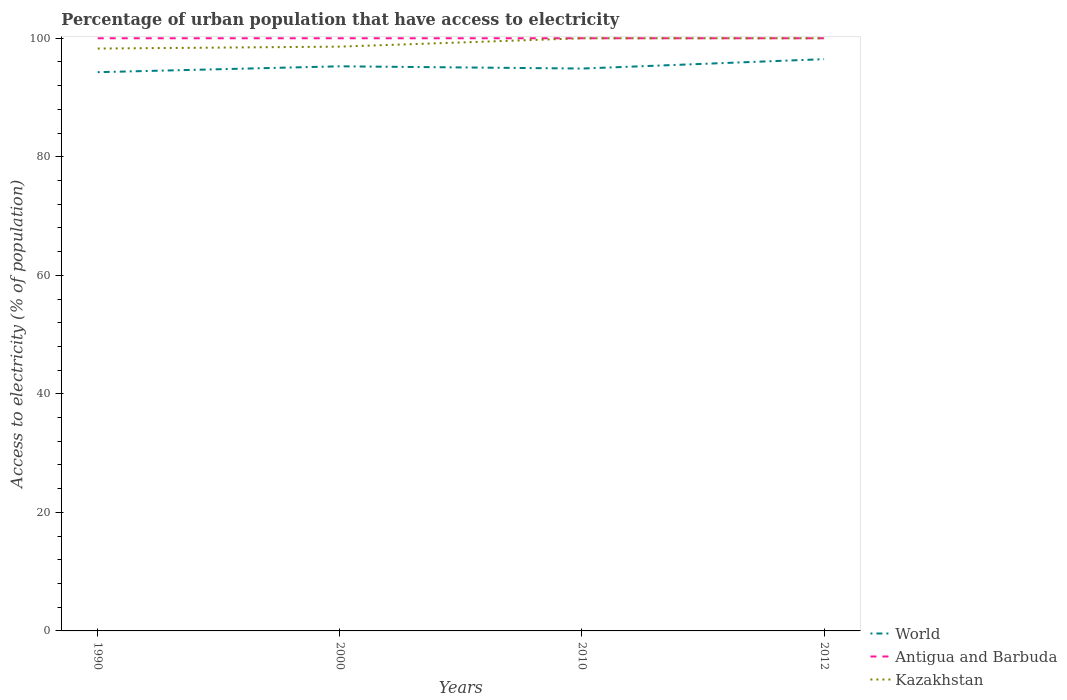Is the number of lines equal to the number of legend labels?
Your answer should be compact. Yes. Across all years, what is the maximum percentage of urban population that have access to electricity in Kazakhstan?
Ensure brevity in your answer.  98.26. What is the difference between two consecutive major ticks on the Y-axis?
Ensure brevity in your answer.  20. Are the values on the major ticks of Y-axis written in scientific E-notation?
Your answer should be very brief. No. Does the graph contain any zero values?
Keep it short and to the point. No. Does the graph contain grids?
Your answer should be very brief. No. How are the legend labels stacked?
Provide a short and direct response. Vertical. What is the title of the graph?
Provide a short and direct response. Percentage of urban population that have access to electricity. What is the label or title of the X-axis?
Provide a succinct answer. Years. What is the label or title of the Y-axis?
Provide a short and direct response. Access to electricity (% of population). What is the Access to electricity (% of population) of World in 1990?
Keep it short and to the point. 94.28. What is the Access to electricity (% of population) in Kazakhstan in 1990?
Ensure brevity in your answer.  98.26. What is the Access to electricity (% of population) in World in 2000?
Offer a terse response. 95.27. What is the Access to electricity (% of population) in Kazakhstan in 2000?
Your answer should be very brief. 98.59. What is the Access to electricity (% of population) in World in 2010?
Offer a very short reply. 94.89. What is the Access to electricity (% of population) in Antigua and Barbuda in 2010?
Provide a short and direct response. 100. What is the Access to electricity (% of population) of Kazakhstan in 2010?
Your response must be concise. 100. What is the Access to electricity (% of population) of World in 2012?
Provide a short and direct response. 96.48. What is the Access to electricity (% of population) of Antigua and Barbuda in 2012?
Your answer should be very brief. 100. Across all years, what is the maximum Access to electricity (% of population) in World?
Your answer should be very brief. 96.48. Across all years, what is the maximum Access to electricity (% of population) of Antigua and Barbuda?
Offer a very short reply. 100. Across all years, what is the minimum Access to electricity (% of population) in World?
Your answer should be compact. 94.28. Across all years, what is the minimum Access to electricity (% of population) in Antigua and Barbuda?
Give a very brief answer. 100. Across all years, what is the minimum Access to electricity (% of population) in Kazakhstan?
Offer a terse response. 98.26. What is the total Access to electricity (% of population) of World in the graph?
Keep it short and to the point. 380.92. What is the total Access to electricity (% of population) of Antigua and Barbuda in the graph?
Ensure brevity in your answer.  400. What is the total Access to electricity (% of population) in Kazakhstan in the graph?
Provide a short and direct response. 396.85. What is the difference between the Access to electricity (% of population) in World in 1990 and that in 2000?
Your answer should be compact. -0.99. What is the difference between the Access to electricity (% of population) of Antigua and Barbuda in 1990 and that in 2000?
Give a very brief answer. 0. What is the difference between the Access to electricity (% of population) in Kazakhstan in 1990 and that in 2000?
Give a very brief answer. -0.32. What is the difference between the Access to electricity (% of population) of World in 1990 and that in 2010?
Give a very brief answer. -0.61. What is the difference between the Access to electricity (% of population) of Antigua and Barbuda in 1990 and that in 2010?
Your response must be concise. 0. What is the difference between the Access to electricity (% of population) in Kazakhstan in 1990 and that in 2010?
Give a very brief answer. -1.74. What is the difference between the Access to electricity (% of population) in World in 1990 and that in 2012?
Your answer should be very brief. -2.2. What is the difference between the Access to electricity (% of population) in Kazakhstan in 1990 and that in 2012?
Provide a succinct answer. -1.74. What is the difference between the Access to electricity (% of population) of World in 2000 and that in 2010?
Your answer should be very brief. 0.38. What is the difference between the Access to electricity (% of population) in Antigua and Barbuda in 2000 and that in 2010?
Provide a succinct answer. 0. What is the difference between the Access to electricity (% of population) of Kazakhstan in 2000 and that in 2010?
Offer a very short reply. -1.41. What is the difference between the Access to electricity (% of population) in World in 2000 and that in 2012?
Your response must be concise. -1.21. What is the difference between the Access to electricity (% of population) of Kazakhstan in 2000 and that in 2012?
Make the answer very short. -1.41. What is the difference between the Access to electricity (% of population) of World in 2010 and that in 2012?
Your response must be concise. -1.59. What is the difference between the Access to electricity (% of population) of Antigua and Barbuda in 2010 and that in 2012?
Provide a succinct answer. 0. What is the difference between the Access to electricity (% of population) in Kazakhstan in 2010 and that in 2012?
Your response must be concise. 0. What is the difference between the Access to electricity (% of population) in World in 1990 and the Access to electricity (% of population) in Antigua and Barbuda in 2000?
Make the answer very short. -5.72. What is the difference between the Access to electricity (% of population) of World in 1990 and the Access to electricity (% of population) of Kazakhstan in 2000?
Give a very brief answer. -4.31. What is the difference between the Access to electricity (% of population) of Antigua and Barbuda in 1990 and the Access to electricity (% of population) of Kazakhstan in 2000?
Your response must be concise. 1.41. What is the difference between the Access to electricity (% of population) in World in 1990 and the Access to electricity (% of population) in Antigua and Barbuda in 2010?
Make the answer very short. -5.72. What is the difference between the Access to electricity (% of population) of World in 1990 and the Access to electricity (% of population) of Kazakhstan in 2010?
Offer a terse response. -5.72. What is the difference between the Access to electricity (% of population) of Antigua and Barbuda in 1990 and the Access to electricity (% of population) of Kazakhstan in 2010?
Offer a terse response. 0. What is the difference between the Access to electricity (% of population) in World in 1990 and the Access to electricity (% of population) in Antigua and Barbuda in 2012?
Give a very brief answer. -5.72. What is the difference between the Access to electricity (% of population) in World in 1990 and the Access to electricity (% of population) in Kazakhstan in 2012?
Offer a very short reply. -5.72. What is the difference between the Access to electricity (% of population) of Antigua and Barbuda in 1990 and the Access to electricity (% of population) of Kazakhstan in 2012?
Provide a short and direct response. 0. What is the difference between the Access to electricity (% of population) in World in 2000 and the Access to electricity (% of population) in Antigua and Barbuda in 2010?
Provide a succinct answer. -4.73. What is the difference between the Access to electricity (% of population) of World in 2000 and the Access to electricity (% of population) of Kazakhstan in 2010?
Provide a succinct answer. -4.73. What is the difference between the Access to electricity (% of population) of World in 2000 and the Access to electricity (% of population) of Antigua and Barbuda in 2012?
Provide a succinct answer. -4.73. What is the difference between the Access to electricity (% of population) of World in 2000 and the Access to electricity (% of population) of Kazakhstan in 2012?
Provide a succinct answer. -4.73. What is the difference between the Access to electricity (% of population) in World in 2010 and the Access to electricity (% of population) in Antigua and Barbuda in 2012?
Your answer should be compact. -5.11. What is the difference between the Access to electricity (% of population) of World in 2010 and the Access to electricity (% of population) of Kazakhstan in 2012?
Ensure brevity in your answer.  -5.11. What is the average Access to electricity (% of population) of World per year?
Your answer should be very brief. 95.23. What is the average Access to electricity (% of population) of Antigua and Barbuda per year?
Offer a terse response. 100. What is the average Access to electricity (% of population) of Kazakhstan per year?
Ensure brevity in your answer.  99.21. In the year 1990, what is the difference between the Access to electricity (% of population) in World and Access to electricity (% of population) in Antigua and Barbuda?
Give a very brief answer. -5.72. In the year 1990, what is the difference between the Access to electricity (% of population) in World and Access to electricity (% of population) in Kazakhstan?
Provide a succinct answer. -3.98. In the year 1990, what is the difference between the Access to electricity (% of population) of Antigua and Barbuda and Access to electricity (% of population) of Kazakhstan?
Make the answer very short. 1.74. In the year 2000, what is the difference between the Access to electricity (% of population) of World and Access to electricity (% of population) of Antigua and Barbuda?
Your answer should be very brief. -4.73. In the year 2000, what is the difference between the Access to electricity (% of population) in World and Access to electricity (% of population) in Kazakhstan?
Keep it short and to the point. -3.32. In the year 2000, what is the difference between the Access to electricity (% of population) in Antigua and Barbuda and Access to electricity (% of population) in Kazakhstan?
Offer a very short reply. 1.41. In the year 2010, what is the difference between the Access to electricity (% of population) in World and Access to electricity (% of population) in Antigua and Barbuda?
Give a very brief answer. -5.11. In the year 2010, what is the difference between the Access to electricity (% of population) in World and Access to electricity (% of population) in Kazakhstan?
Keep it short and to the point. -5.11. In the year 2012, what is the difference between the Access to electricity (% of population) in World and Access to electricity (% of population) in Antigua and Barbuda?
Ensure brevity in your answer.  -3.52. In the year 2012, what is the difference between the Access to electricity (% of population) of World and Access to electricity (% of population) of Kazakhstan?
Your response must be concise. -3.52. What is the ratio of the Access to electricity (% of population) of Antigua and Barbuda in 1990 to that in 2010?
Keep it short and to the point. 1. What is the ratio of the Access to electricity (% of population) of Kazakhstan in 1990 to that in 2010?
Offer a terse response. 0.98. What is the ratio of the Access to electricity (% of population) in World in 1990 to that in 2012?
Offer a terse response. 0.98. What is the ratio of the Access to electricity (% of population) of Kazakhstan in 1990 to that in 2012?
Give a very brief answer. 0.98. What is the ratio of the Access to electricity (% of population) of Kazakhstan in 2000 to that in 2010?
Ensure brevity in your answer.  0.99. What is the ratio of the Access to electricity (% of population) of World in 2000 to that in 2012?
Make the answer very short. 0.99. What is the ratio of the Access to electricity (% of population) in Kazakhstan in 2000 to that in 2012?
Give a very brief answer. 0.99. What is the ratio of the Access to electricity (% of population) in World in 2010 to that in 2012?
Offer a terse response. 0.98. What is the ratio of the Access to electricity (% of population) of Kazakhstan in 2010 to that in 2012?
Make the answer very short. 1. What is the difference between the highest and the second highest Access to electricity (% of population) in World?
Offer a very short reply. 1.21. What is the difference between the highest and the lowest Access to electricity (% of population) of World?
Your response must be concise. 2.2. What is the difference between the highest and the lowest Access to electricity (% of population) in Kazakhstan?
Provide a succinct answer. 1.74. 